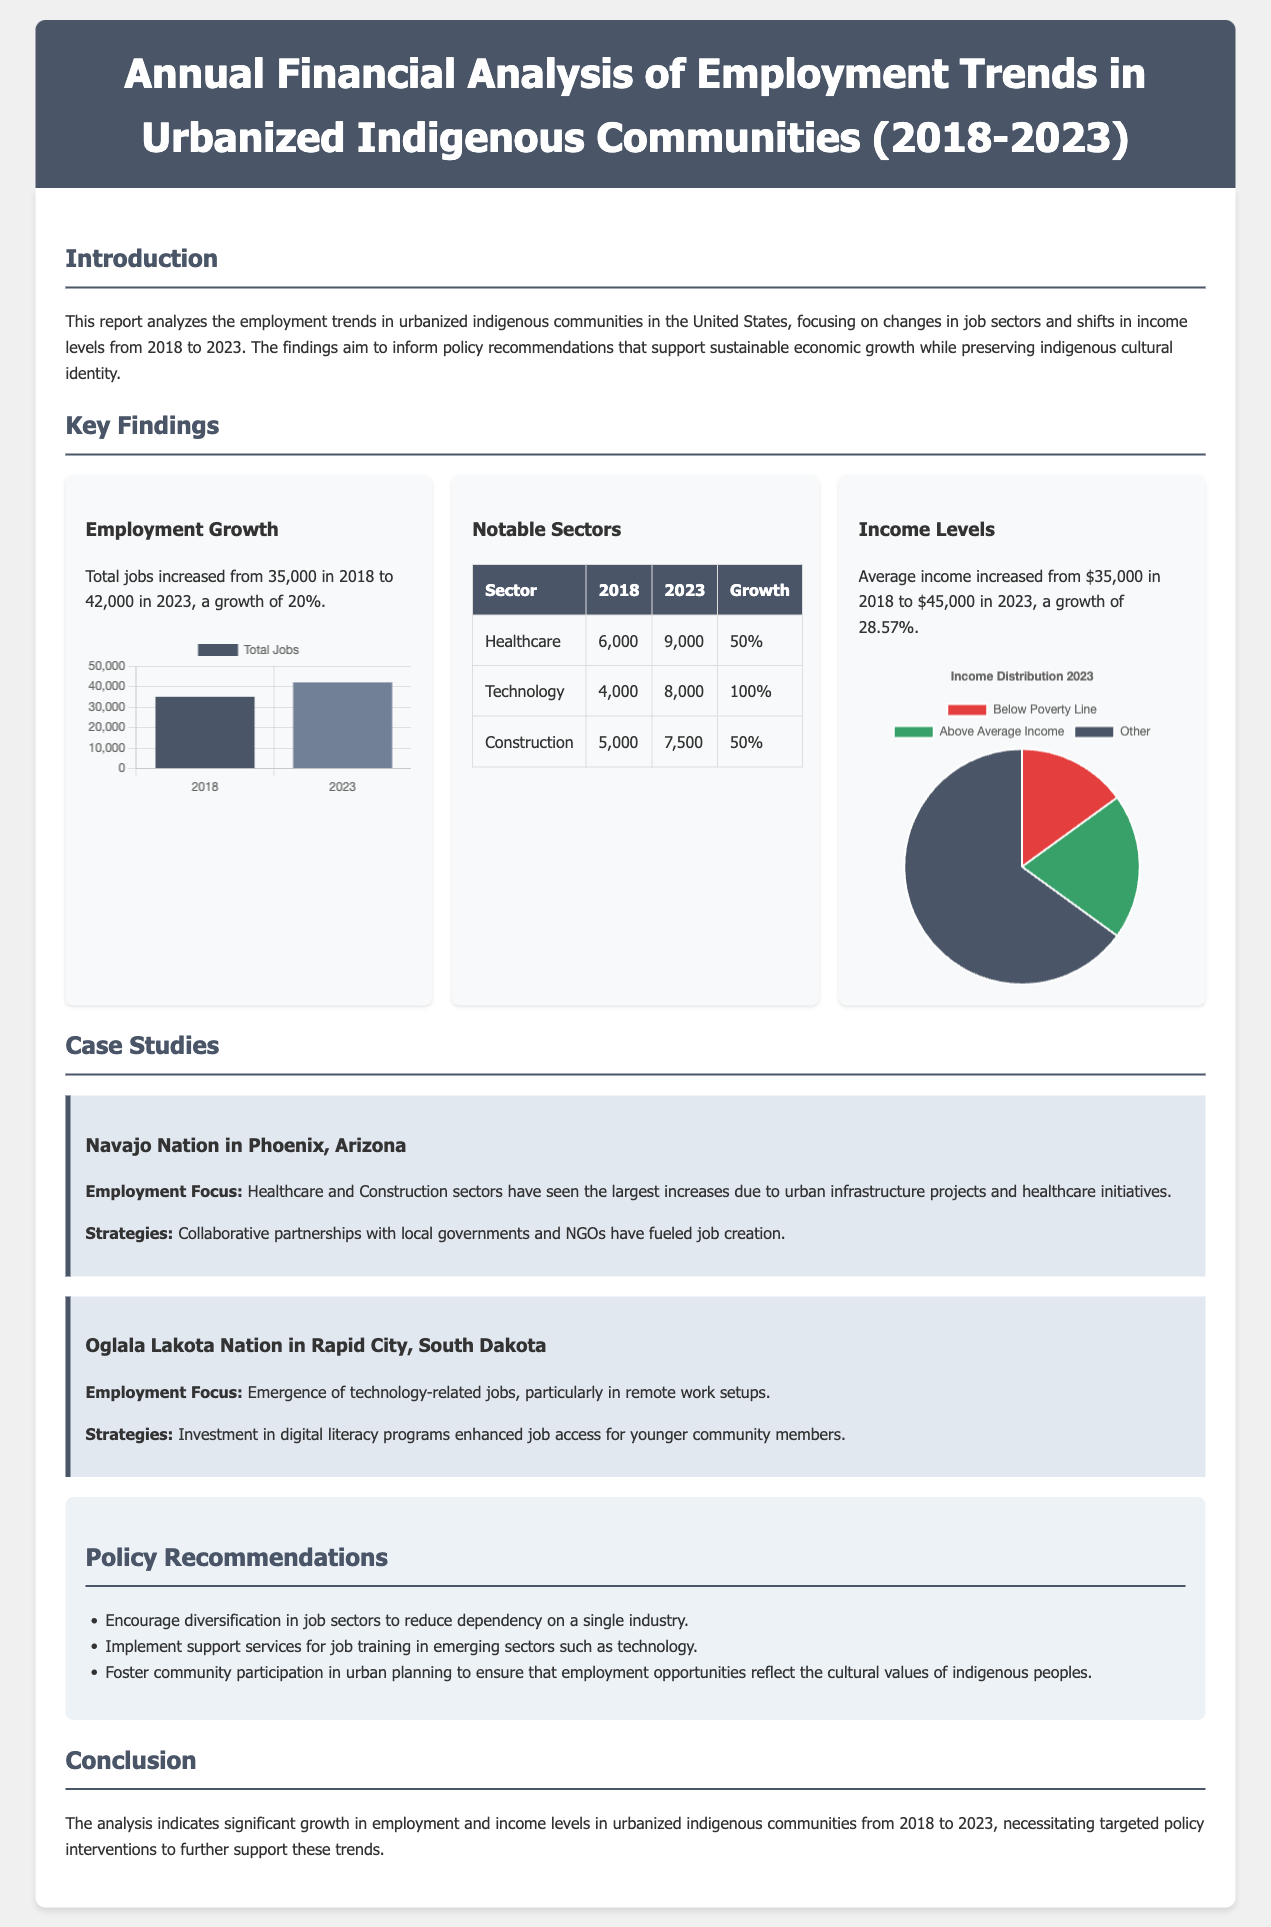what was the total employment in 2018? The total employment in 2018 was 35,000, as stated in the report.
Answer: 35,000 what is the average income in 2023? The average income in 2023 increased to $45,000, according to the key findings.
Answer: $45,000 which sector saw the highest growth from 2018 to 2023? The Technology sector experienced the highest growth of 100%, indicating a notable increase in jobs.
Answer: Technology what is the growth percentage of total jobs from 2018 to 2023? Total jobs increased from 35,000 to 42,000, resulting in a growth rate of 20%.
Answer: 20% how many jobs were created in the Healthcare sector by 2023? By 2023, the Healthcare sector created an additional 3,000 jobs, growing from 6,000 to 9,000.
Answer: 3,000 what percentage of income distribution in 2023 falls under "Below Poverty Line"? The report indicates that 15% of the population falls under the "Below Poverty Line" category in the income distribution for 2023.
Answer: 15% what are the three case study locations mentioned in the report? The case studies focus on the Navajo Nation in Phoenix, Arizona, and the Oglala Lakota Nation in Rapid City, South Dakota.
Answer: Navajo Nation, Oglala Lakota Nation what is one policy recommendation made in the report? One policy recommendation is to implement support services for job training in emerging sectors such as technology.
Answer: Job training support services how many total sectors are highlighted in the notable sectors table? The notable sectors table highlights three sectors, including Healthcare, Technology, and Construction.
Answer: Three 